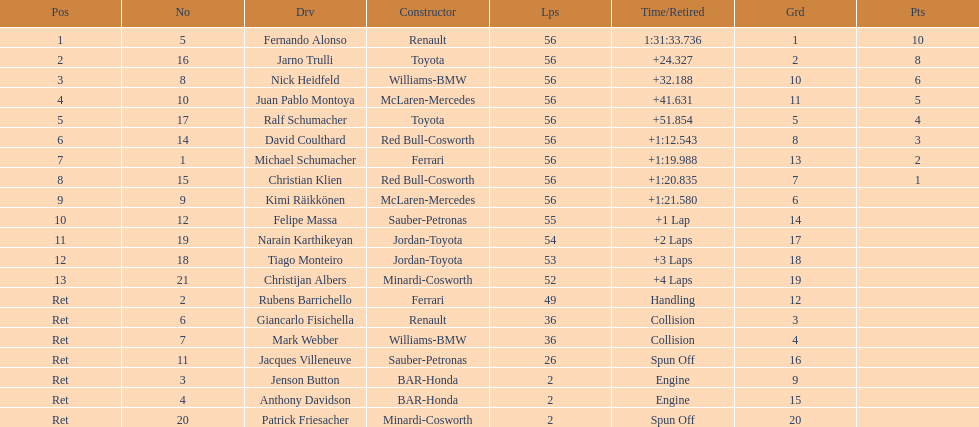What driver finished first? Fernando Alonso. 